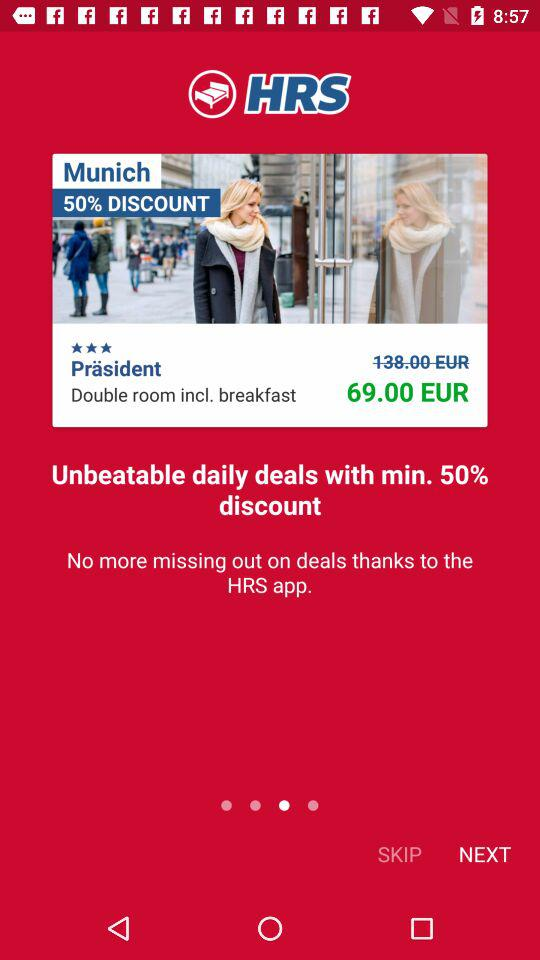What is the chargeable amount after discount? The chargeable amount after discount is 69.00 EUR. 